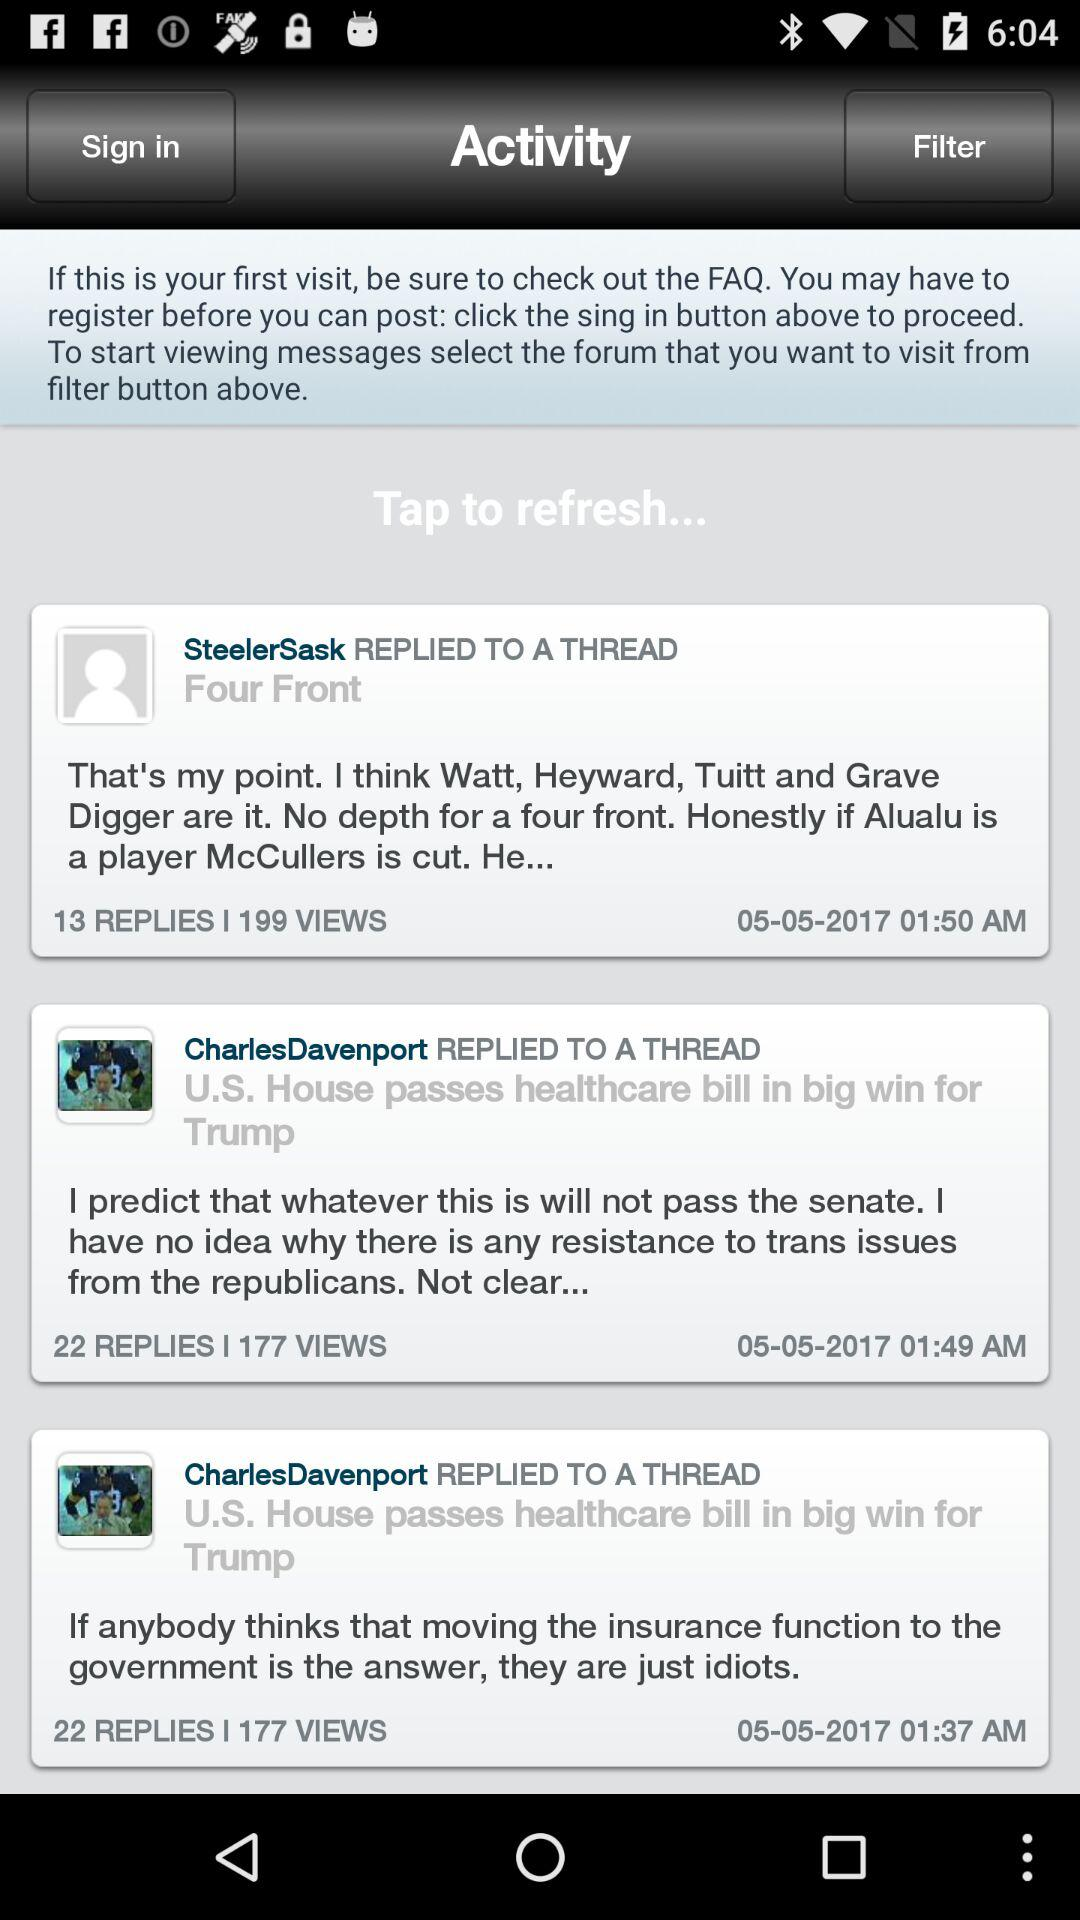How many replies on SteelersSask's post? There are 13 replies. 